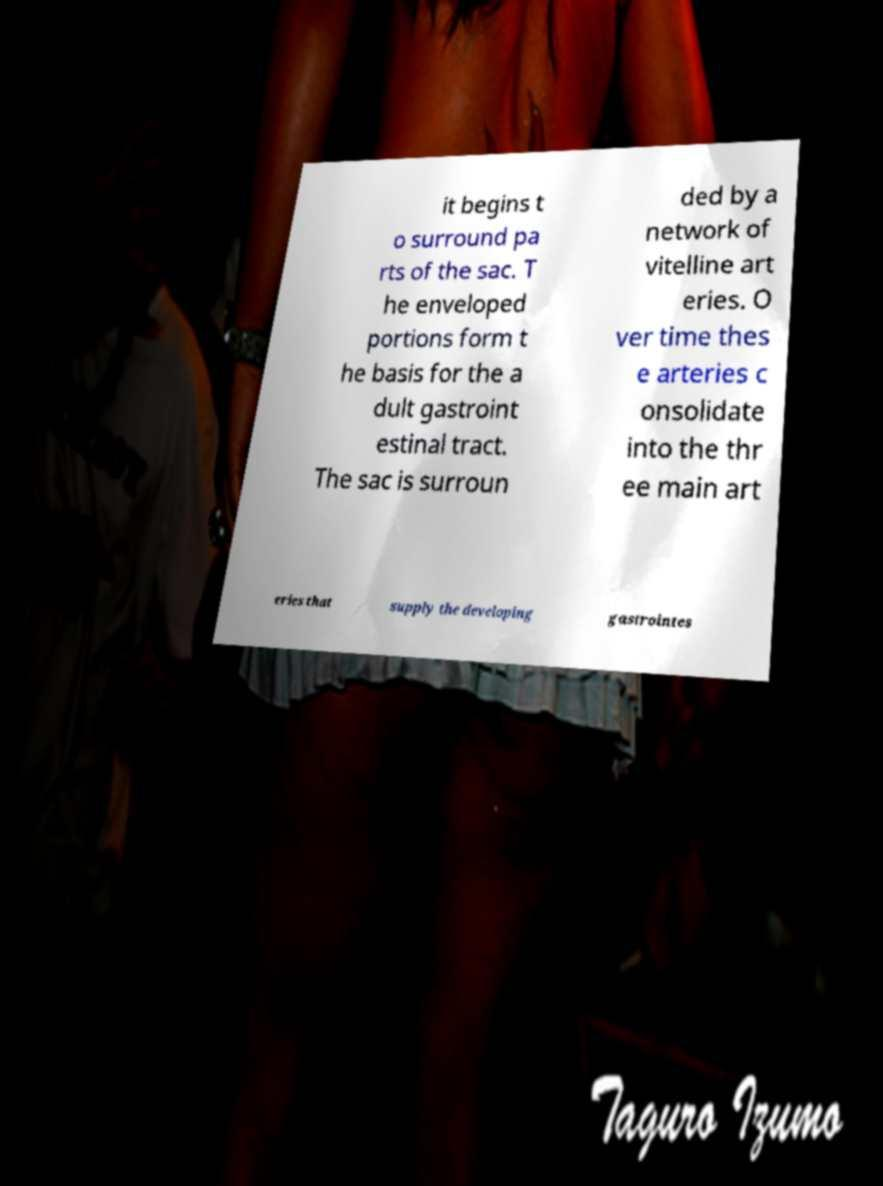Could you extract and type out the text from this image? it begins t o surround pa rts of the sac. T he enveloped portions form t he basis for the a dult gastroint estinal tract. The sac is surroun ded by a network of vitelline art eries. O ver time thes e arteries c onsolidate into the thr ee main art eries that supply the developing gastrointes 